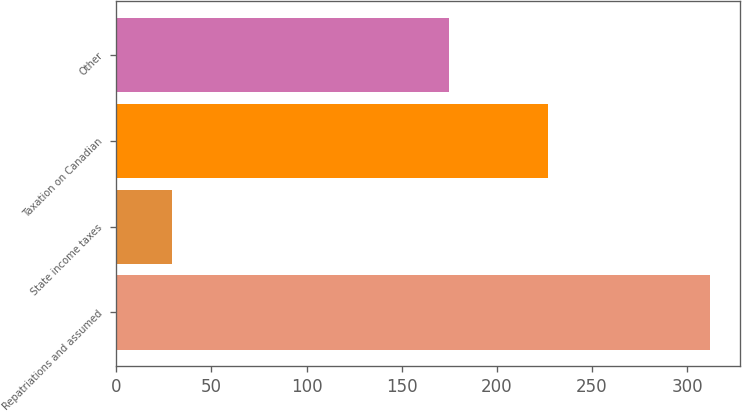Convert chart to OTSL. <chart><loc_0><loc_0><loc_500><loc_500><bar_chart><fcel>Repatriations and assumed<fcel>State income taxes<fcel>Taxation on Canadian<fcel>Other<nl><fcel>312<fcel>29<fcel>227<fcel>175<nl></chart> 